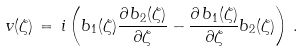Convert formula to latex. <formula><loc_0><loc_0><loc_500><loc_500>v ( \zeta ) \, = \, i \left ( b _ { 1 } ( \zeta ) \frac { \partial \, b _ { 2 } ( \zeta ) } { \partial \zeta } - \frac { \partial \, b _ { 1 } ( \zeta ) } { \partial \zeta } b _ { 2 } ( \zeta ) \right ) \, .</formula> 